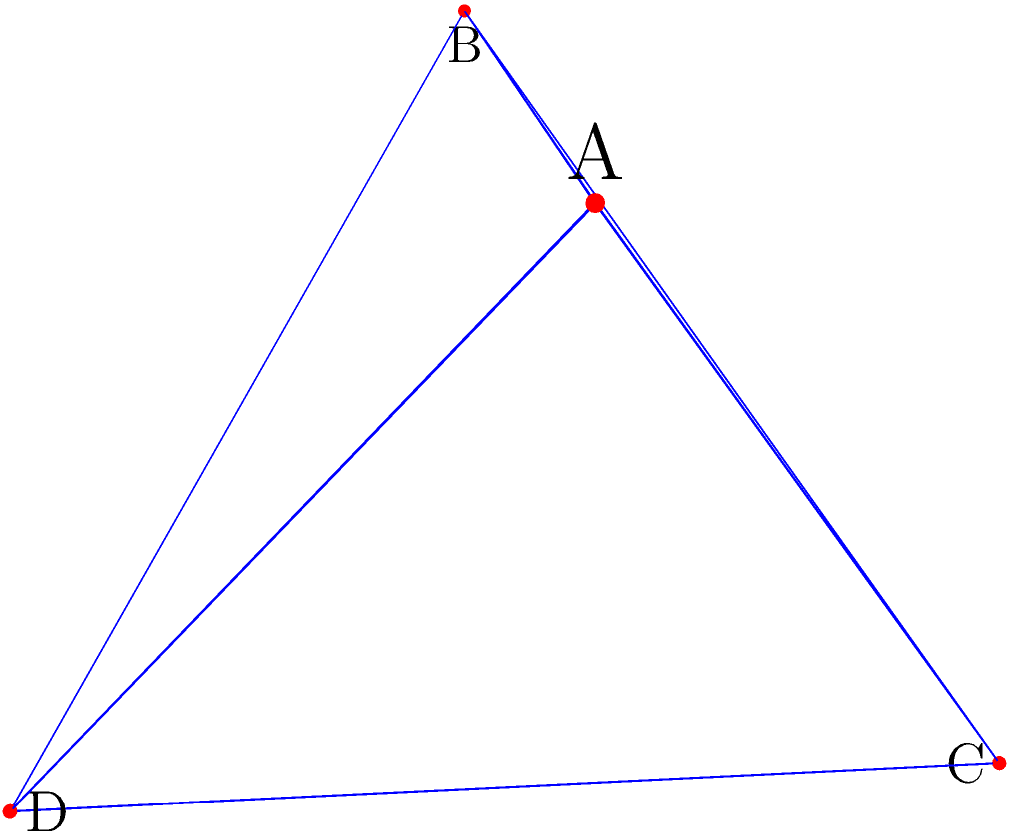Consider the tetrahedral molecule shown above. Determine the order of its full symmetry group and identify the number of distinct rotational symmetry operations (excluding the identity operation) in this group. To analyze the symmetry group of a tetrahedral molecule, we'll proceed step-by-step:

1. Identify symmetry elements:
   a) 4 $C_3$ axes (through each vertex to the opposite face)
   b) 3 $C_2$ axes (through the midpoints of opposite edges)
   c) 6 reflection planes (through each edge and the midpoint of the opposite edge)
   d) The identity operation $E$
   e) Inversion center $i$ (if the molecule has $T_d$ symmetry)

2. Count rotational symmetry operations:
   a) $C_3$ rotations: 4 axes × 2 rotations each = 8 operations
   b) $C_2$ rotations: 3 axes × 1 rotation each = 3 operations

3. Total number of distinct rotational symmetry operations (excluding identity):
   8 + 3 = 11

4. Determine the full symmetry group:
   If the molecule has $T_d$ symmetry (no inversion center):
   - Order = 24 (12 rotations including identity + 12 improper rotations)
   If the molecule has $O_h$ symmetry (with inversion center):
   - Order = 48 (24 proper rotations + 24 improper rotations)

5. Given that we're asked for the full symmetry group, we assume $O_h$ symmetry, which is the highest possible symmetry for a tetrahedral arrangement.

Therefore, the order of the full symmetry group is 48, and the number of distinct rotational symmetry operations (excluding the identity) is 11.
Answer: Order: 48; Distinct rotations: 11 